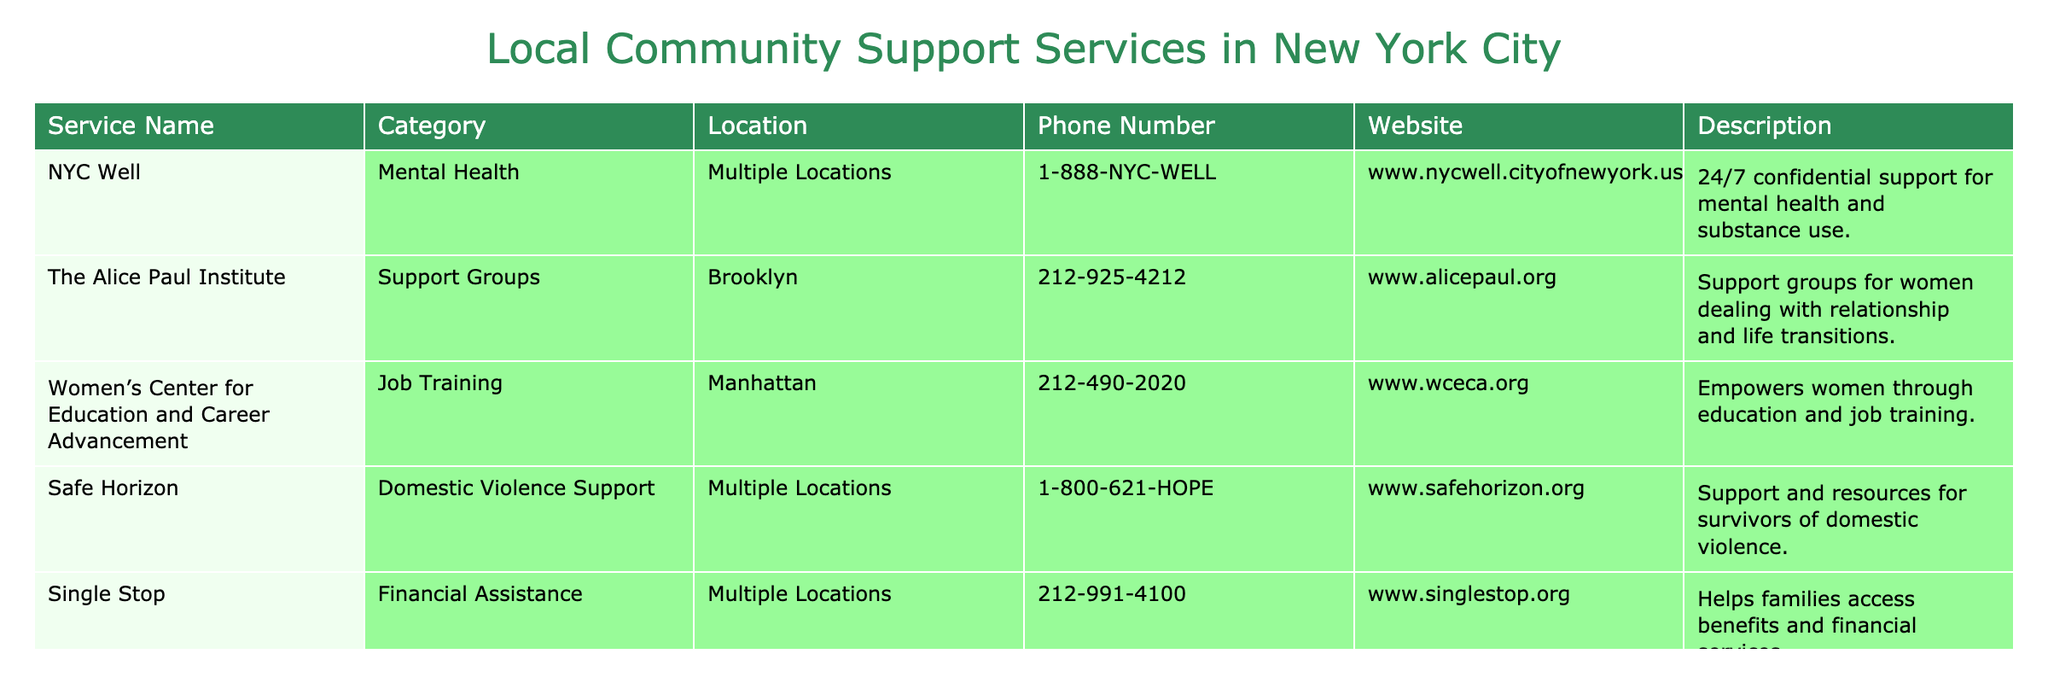What is the phone number for NYC Well? The phone number for NYC Well can be directly found in the table under the Phone Number column. It is listed as 1-888-NYC-WELL.
Answer: 1-888-NYC-WELL Which service provides job training for women? From the Description column, the service that provides job training specifically for women is the Women’s Center for Education and Career Advancement.
Answer: Women’s Center for Education and Career Advancement How many services listed are located in multiple locations? By looking at the Location column, I can see that NYC Well, Safe Horizon, and Single Stop are noted as having multiple locations. Therefore, there are 3 services in total that have this designation.
Answer: 3 Is Safe Horizon focused on mental health support? Safe Horizon is categorized under Domestic Violence Support in the table. Therefore, its focus is not specifically on mental health support but rather on domestic violence resources.
Answer: No What is the total number of services that deal with financial assistance or job training? First, I identify the services listed for financial assistance (Single Stop) and job training (Women’s Center for Education and Career Advancement). Adding them gives 1 (Single Stop) + 1 (Women’s Center) = 2 services.
Answer: 2 Does The Alice Paul Institute have a website? The table states the website for The Alice Paul Institute as www.alicepaul.org, indicating that it does indeed have a website.
Answer: Yes Which service has the longest phone number? By comparing the lengths of the phone numbers shown in the Phone Number column, I find that 1-888-NYC-WELL has the most digits, making it the longest phone number among the listed services.
Answer: 1-888-NYC-WELL Which service is specifically designed for survivors of domestic violence? The table clearly labels Safe Horizon in the Description column as a support service for survivors of domestic violence.
Answer: Safe Horizon 